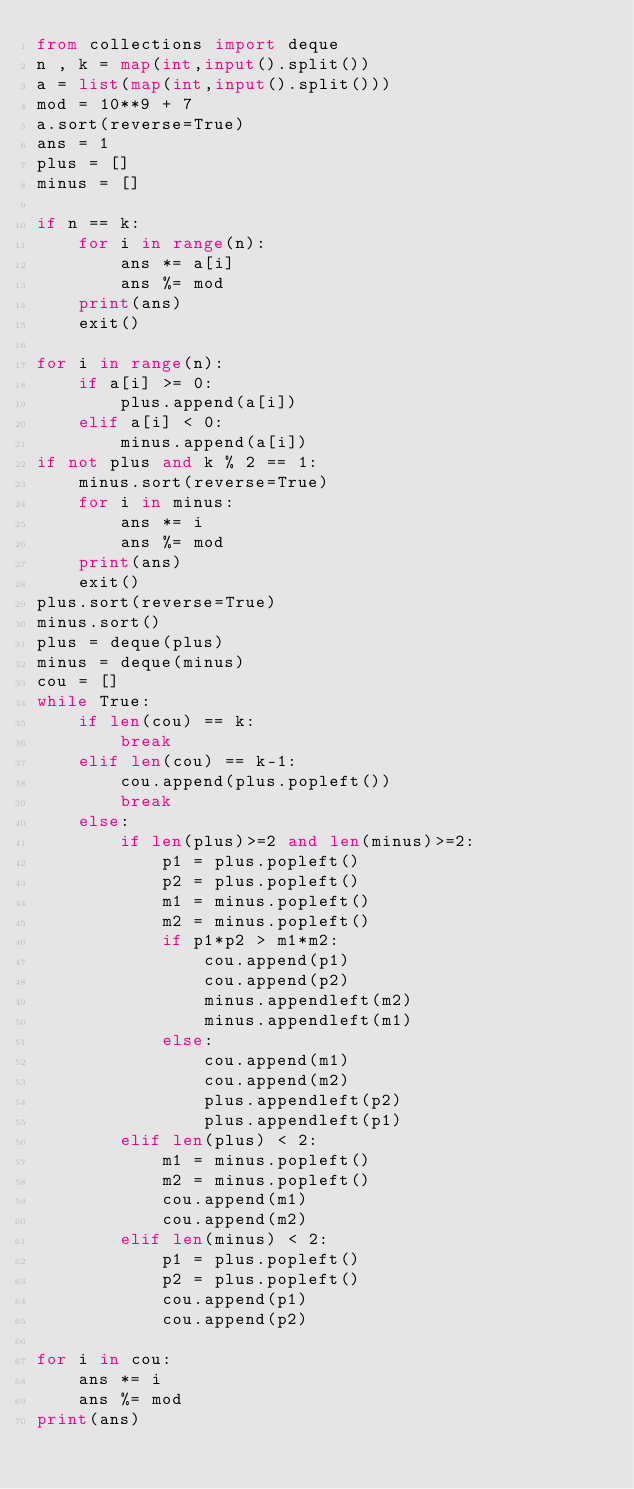Convert code to text. <code><loc_0><loc_0><loc_500><loc_500><_Python_>from collections import deque
n , k = map(int,input().split())
a = list(map(int,input().split()))
mod = 10**9 + 7
a.sort(reverse=True)
ans = 1
plus = []
minus = []

if n == k:
    for i in range(n):
        ans *= a[i]
        ans %= mod
    print(ans)
    exit()
    
for i in range(n):
    if a[i] >= 0:
        plus.append(a[i])
    elif a[i] < 0:
        minus.append(a[i])
if not plus and k % 2 == 1:
    minus.sort(reverse=True)
    for i in minus:
        ans *= i
        ans %= mod
    print(ans)
    exit()
plus.sort(reverse=True)
minus.sort()
plus = deque(plus)
minus = deque(minus)
cou = []
while True:
    if len(cou) == k:
        break
    elif len(cou) == k-1:
        cou.append(plus.popleft())
        break
    else:
        if len(plus)>=2 and len(minus)>=2:
            p1 = plus.popleft()
            p2 = plus.popleft()
            m1 = minus.popleft()
            m2 = minus.popleft()
            if p1*p2 > m1*m2:
                cou.append(p1)
                cou.append(p2)
                minus.appendleft(m2)
                minus.appendleft(m1)
            else:
                cou.append(m1)
                cou.append(m2)
                plus.appendleft(p2)
                plus.appendleft(p1)
        elif len(plus) < 2:
            m1 = minus.popleft()
            m2 = minus.popleft()
            cou.append(m1)
            cou.append(m2)
        elif len(minus) < 2:
            p1 = plus.popleft()
            p2 = plus.popleft()
            cou.append(p1)
            cou.append(p2)
        
for i in cou:
    ans *= i
    ans %= mod
print(ans)</code> 